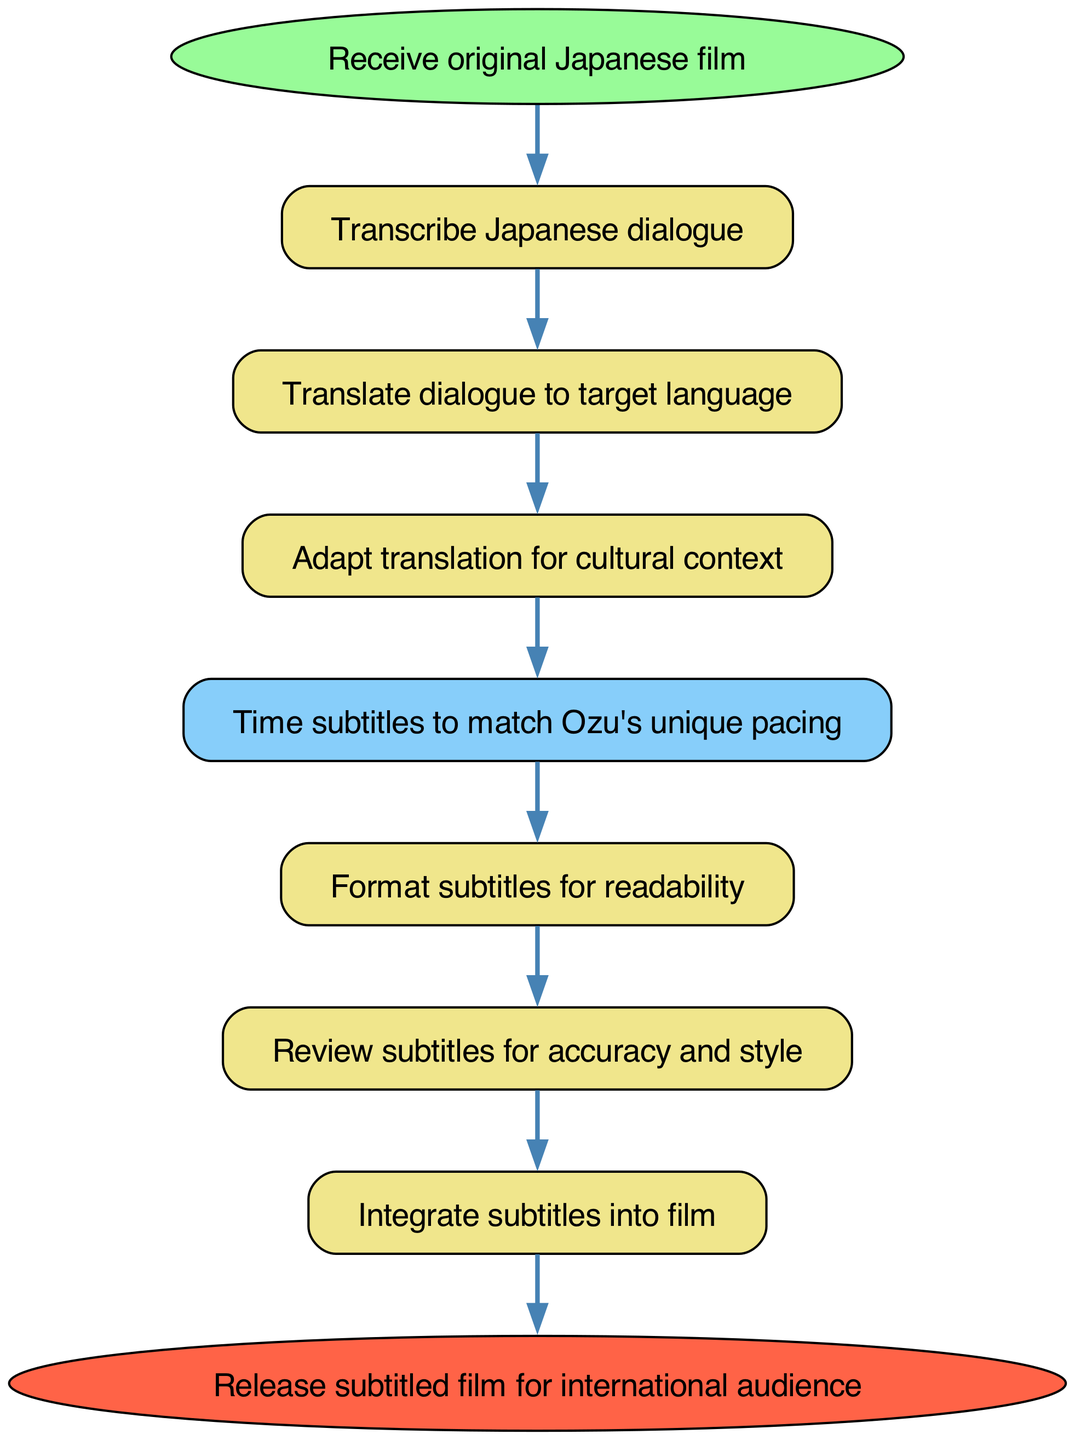What is the first step in the process? The first step, as indicated in the diagram, is "Receive original Japanese film." This is represented by the "start" node, which flows into the next step.
Answer: Receive original Japanese film How many nodes are present in the diagram? By counting all distinct elements in the diagram, including start and end nodes, there are a total of 9 nodes. This includes each unique activity represented in the flowchart.
Answer: 9 What is the last step before releasing the subtitled film? The last step before releasing the film, indicated by the flow from the "integrate" node, is "Release subtitled film for international audience," represented by the "end" node.
Answer: Integrate subtitles into film What happens after adapting the translation? After the "adapt" step, the process flows to the "time" step, where subtitles are timed to match the film's unique pacing. This indicates that timing is crucial following translation adaptation.
Answer: Time subtitles to match Ozu's unique pacing Which node shares a direct connection with the "review" node? The "review" node has a direct connection flowing into it from the "format" node. This shows that formatting subtitles precedes reviewing them for accuracy and style.
Answer: Format subtitles for readability What process involves cultural context? The process that involves cultural context is "Adapt translation for cultural context." This step ensures that the translation resonates with the target audience's cultural nuances.
Answer: Adapt translation for cultural context How many edges connect the steps in the diagram? There are a total of 8 edges in the diagram, which indicate the flow from one step to the next within the subtitling process. Each edge shows the progression of tasks.
Answer: 8 What is the color of the starting node? The starting node is represented by the color light green, specifically indicated as "#98FB98" in the diagram. This color coding visually distinguishes the starting point of the process.
Answer: Light green What is the purpose of the "time" step in the process? The purpose of the "time" step is to ensure that subtitles are timed to match Yasujirō Ozu's unique pacing, which reflects the importance of rhythm in his filmmaking style.
Answer: Time subtitles to match Ozu's unique pacing 